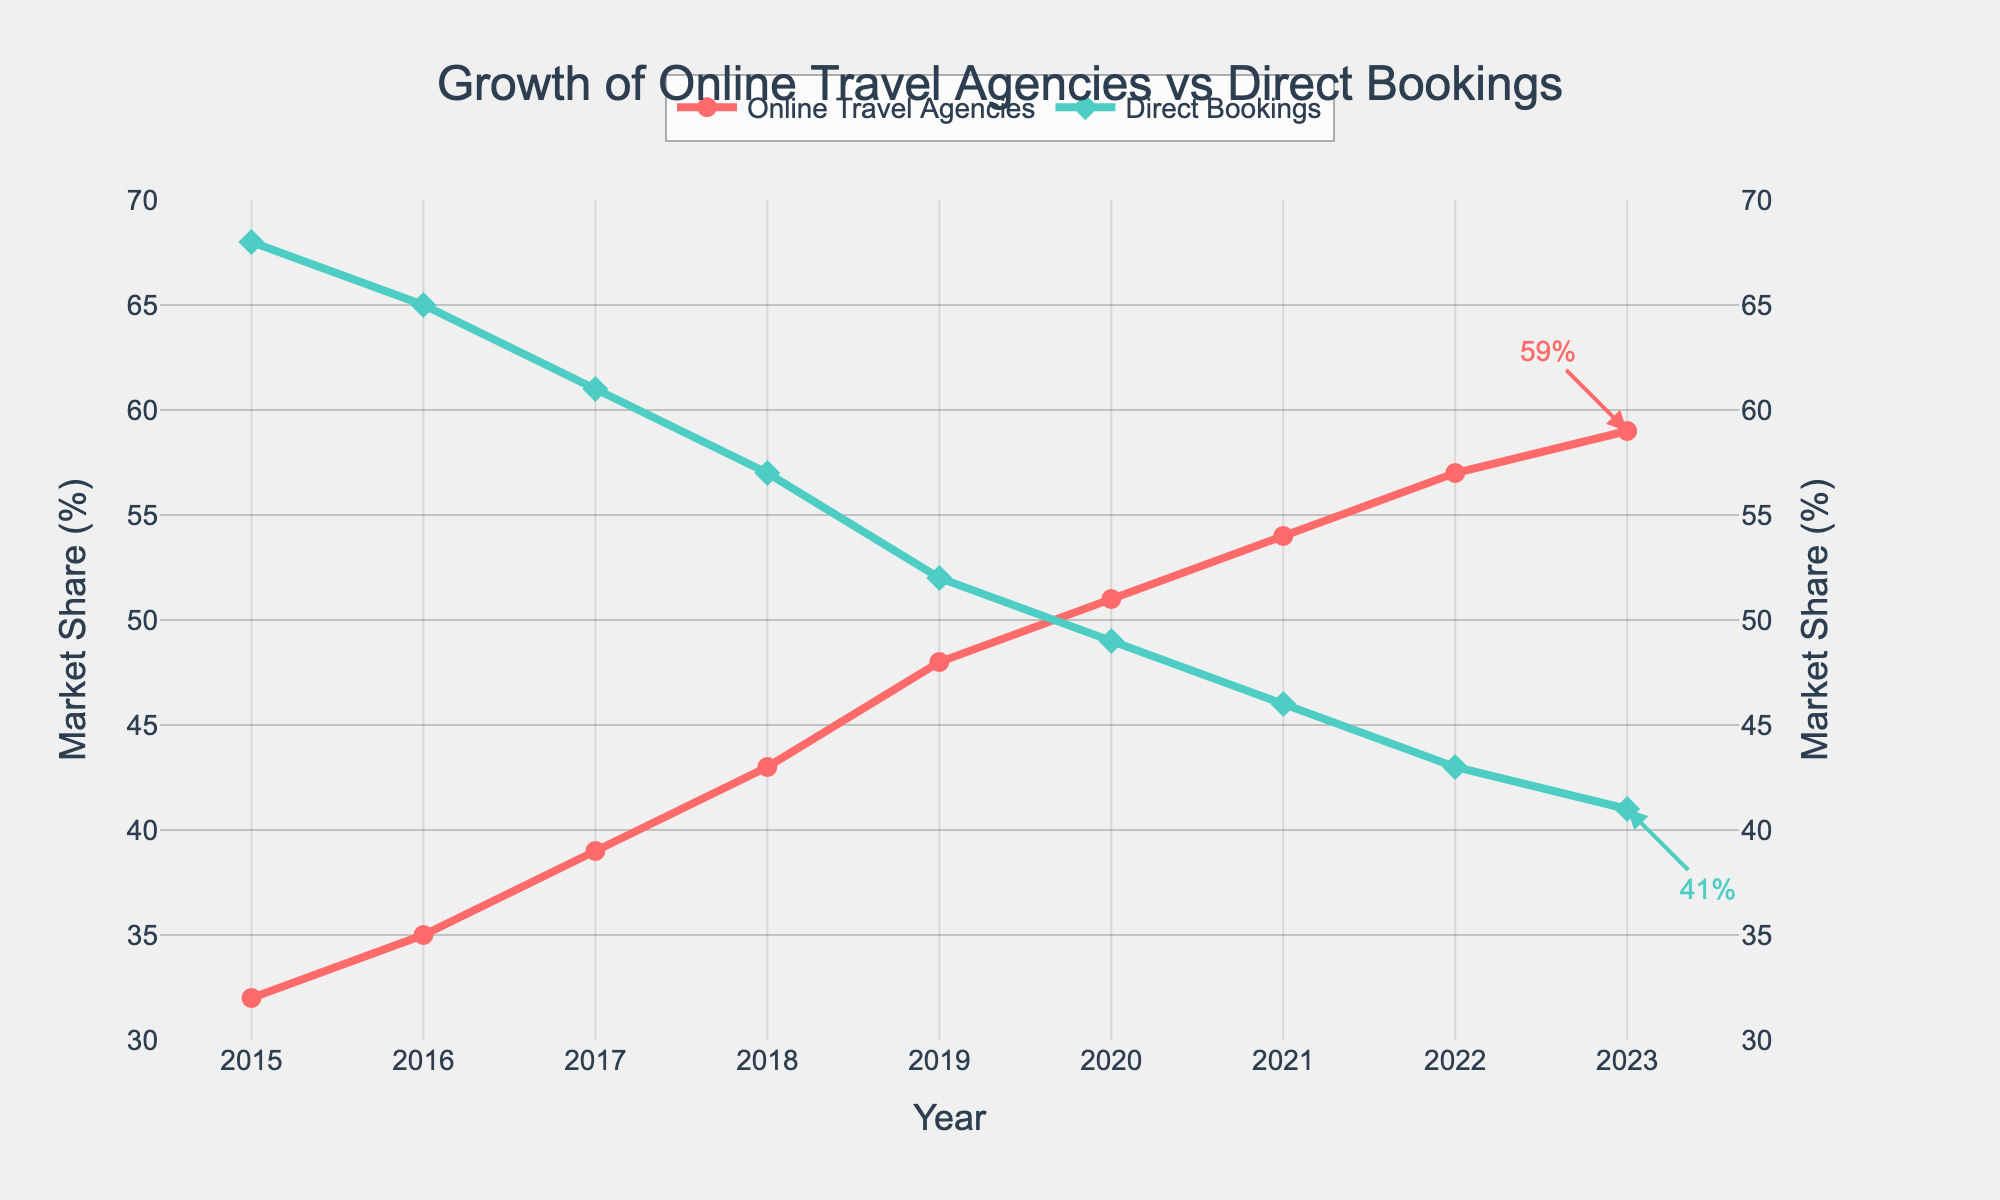What is the market share of Online Travel Agencies and Direct Bookings in 2023? To find the market share in 2023, look at the points on the graph for the year 2023. According to the annotations, Online Travel Agencies have a market share of 59% and Direct Bookings have a market share of 41%.
Answer: Online Travel Agencies: 59%, Direct Bookings: 41% Which year did Online Travel Agencies first surpass 50% market share? To determine when Online Travel Agencies' market share exceeded 50%, check the point at which their value first goes over 50% on the graph. This happens in 2020.
Answer: 2020 What is the trend of Direct Bookings market share from 2015 to 2023? To interpret the trend of Direct Bookings market share, observe the line representing Direct Bookings from 2015 to 2023. The line shows a consistent decline from 68% in 2015 to 41% in 2023.
Answer: Declining Compare the rate of change in market share for Online Travel Agencies between 2015-2017 and 2019-2021. Which period had a faster increase? First calculate the increase in market share for both periods. From 2015 to 2017, the increase is from 32% to 39%, resulting in an increase of 7%. From 2019 to 2021, the increase is from 48% to 54%, resulting in an increase of 6%. Therefore, the period 2015-2017 had a faster rate of increase.
Answer: 2015-2017 In which year were the market shares of Online Travel Agencies and Direct Bookings equal, and what was that percentage? To find the year when both were equal, look for the point where the lines intersect. They intersect at the 49% mark, which happens in 2020.
Answer: 2020, 49% What is the average yearly market share of Online Travel Agencies from 2015 to 2023? Calculate the average share by adding up the shares from all years and dividing by the number of years. (32+35+39+43+48+51+54+57+59)/9 = 46.444.
Answer: 46.44% By how many percentage points did the market share of Direct Bookings drop from 2015 to 2023? Subtract the market share in 2023 from that in 2015. 68% - 41% = 27%.
Answer: 27% What percentage of the total market share did Online Travel Agencies gain from 2019 to 2023? Calculate the difference in Online Travel Agencies’ share between 2019 and 2023. 59% - 48% = 11%.
Answer: 11% Which visual attribute makes it easy to identify Online Travel Agencies' data on the chart? The line representing Online Travel Agencies is red with circles as markers, making it easily distinguishable.
Answer: Red color with circle markers 